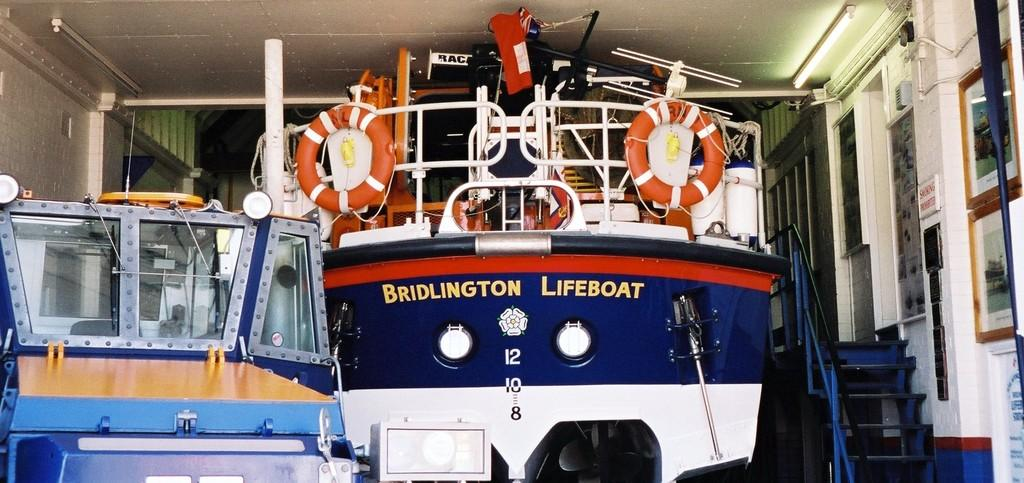What is the main subject of the image? The main subject of the image is a boat. Can you describe the color of the boat? The boat is in blue and white color. What feature can be seen on the right side of the boat? There is a staircase on the right side of the boat. What type of cloth is draped over the boat in the image? There is no cloth draped over the boat in the image. What harmony is being played by the musicians on the boat? There are no musicians or any indication of music in the image. 